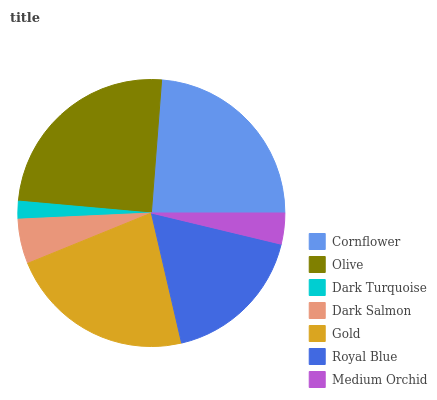Is Dark Turquoise the minimum?
Answer yes or no. Yes. Is Olive the maximum?
Answer yes or no. Yes. Is Olive the minimum?
Answer yes or no. No. Is Dark Turquoise the maximum?
Answer yes or no. No. Is Olive greater than Dark Turquoise?
Answer yes or no. Yes. Is Dark Turquoise less than Olive?
Answer yes or no. Yes. Is Dark Turquoise greater than Olive?
Answer yes or no. No. Is Olive less than Dark Turquoise?
Answer yes or no. No. Is Royal Blue the high median?
Answer yes or no. Yes. Is Royal Blue the low median?
Answer yes or no. Yes. Is Gold the high median?
Answer yes or no. No. Is Cornflower the low median?
Answer yes or no. No. 